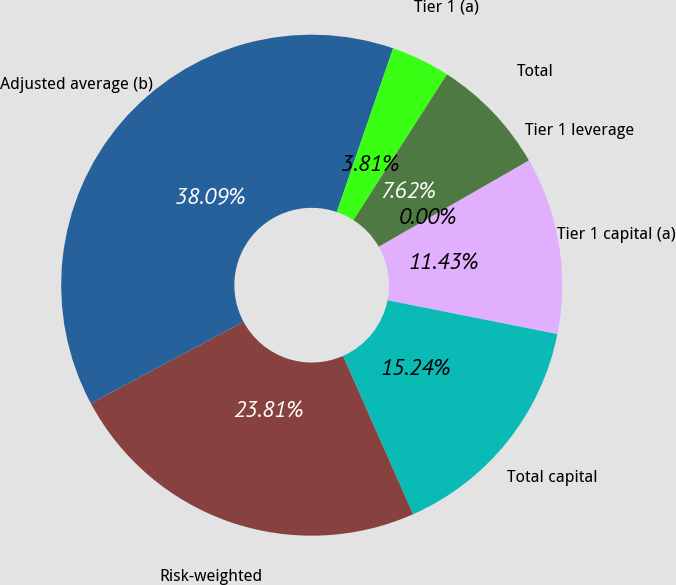<chart> <loc_0><loc_0><loc_500><loc_500><pie_chart><fcel>Tier 1 capital (a)<fcel>Total capital<fcel>Risk-weighted<fcel>Adjusted average (b)<fcel>Tier 1 (a)<fcel>Total<fcel>Tier 1 leverage<nl><fcel>11.43%<fcel>15.24%<fcel>23.81%<fcel>38.09%<fcel>3.81%<fcel>7.62%<fcel>0.0%<nl></chart> 